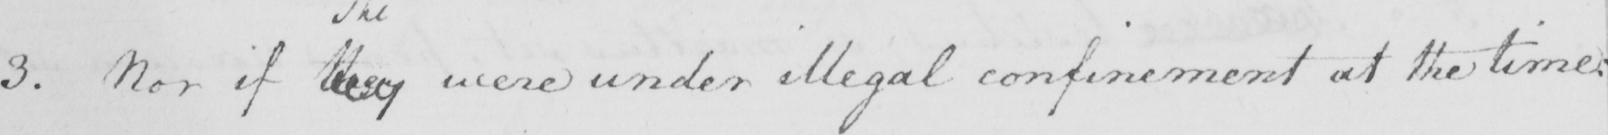Can you tell me what this handwritten text says? 3 . Nor if they were under illegal confinement at the time : 